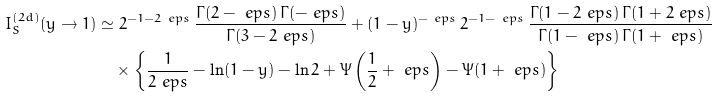<formula> <loc_0><loc_0><loc_500><loc_500>I _ { S } ^ { ( 2 d ) } ( y \to 1 ) & \simeq 2 ^ { - 1 - 2 \ e p s } \, \frac { \Gamma ( 2 - \ e p s ) \, \Gamma ( - \ e p s ) } { \Gamma ( 3 - 2 \ e p s ) } + ( 1 - y ) ^ { - \ e p s } \, 2 ^ { - 1 - \ e p s } \, \frac { \Gamma ( 1 - 2 \ e p s ) \, \Gamma ( 1 + 2 \ e p s ) } { \Gamma ( 1 - \ e p s ) \, \Gamma ( 1 + \ e p s ) } \\ & \quad \times \left \{ \frac { 1 } { 2 \ e p s } - \ln ( 1 - y ) - \ln 2 + \Psi \left ( \frac { 1 } { 2 } + \ e p s \right ) - \Psi ( 1 + \ e p s ) \right \}</formula> 